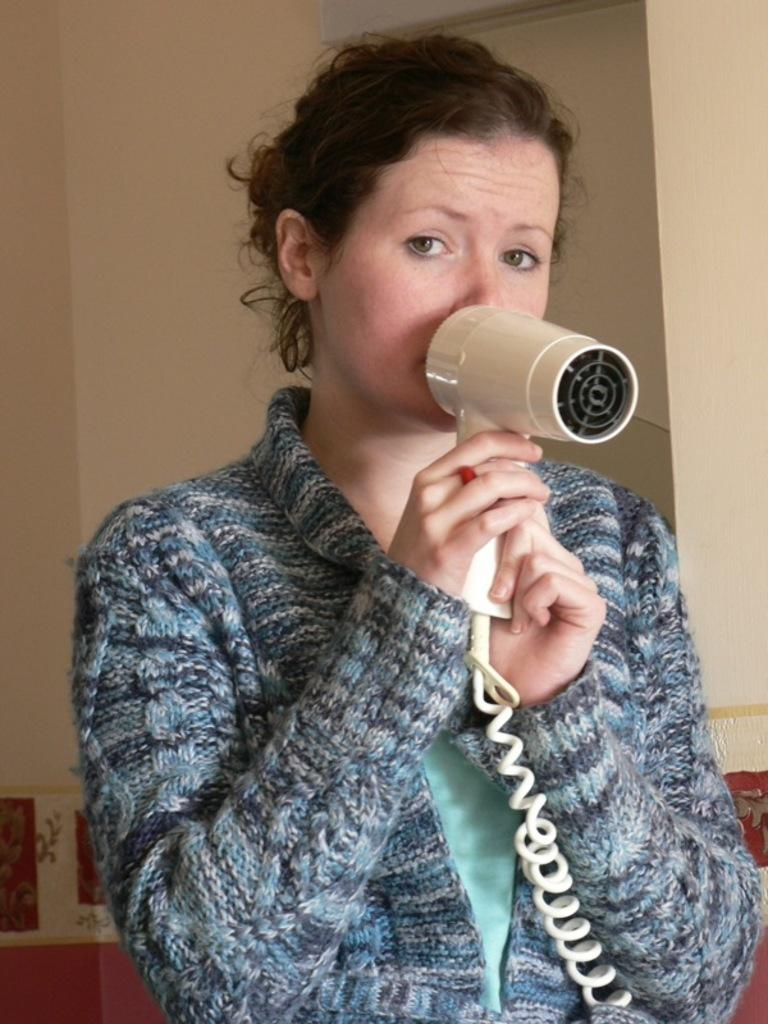Who is present in the image? There is a woman in the image. What is the woman holding in the image? The woman is holding a hair dryer. What can be seen in the background of the image? There is a cream-colored wall in the background of the image. How much sugar is in the hair dryer in the image? There is no sugar present in the hair dryer in the image, as it is an electrical appliance used for drying hair. 